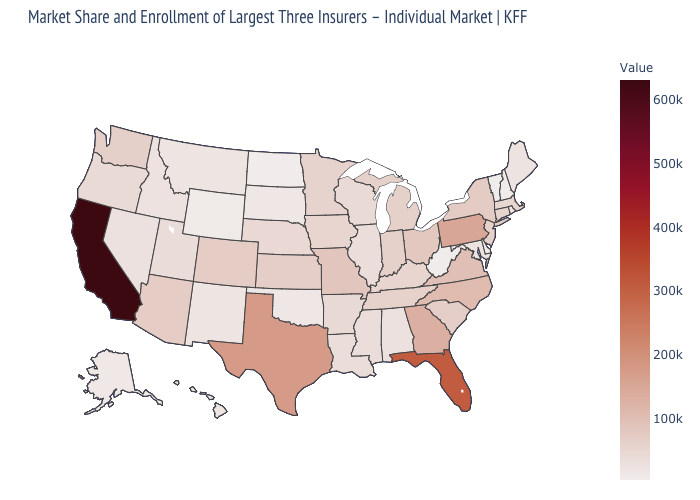Which states have the lowest value in the USA?
Answer briefly. Delaware. Does California have the highest value in the West?
Short answer required. Yes. Among the states that border Oklahoma , does Texas have the highest value?
Keep it brief. Yes. 